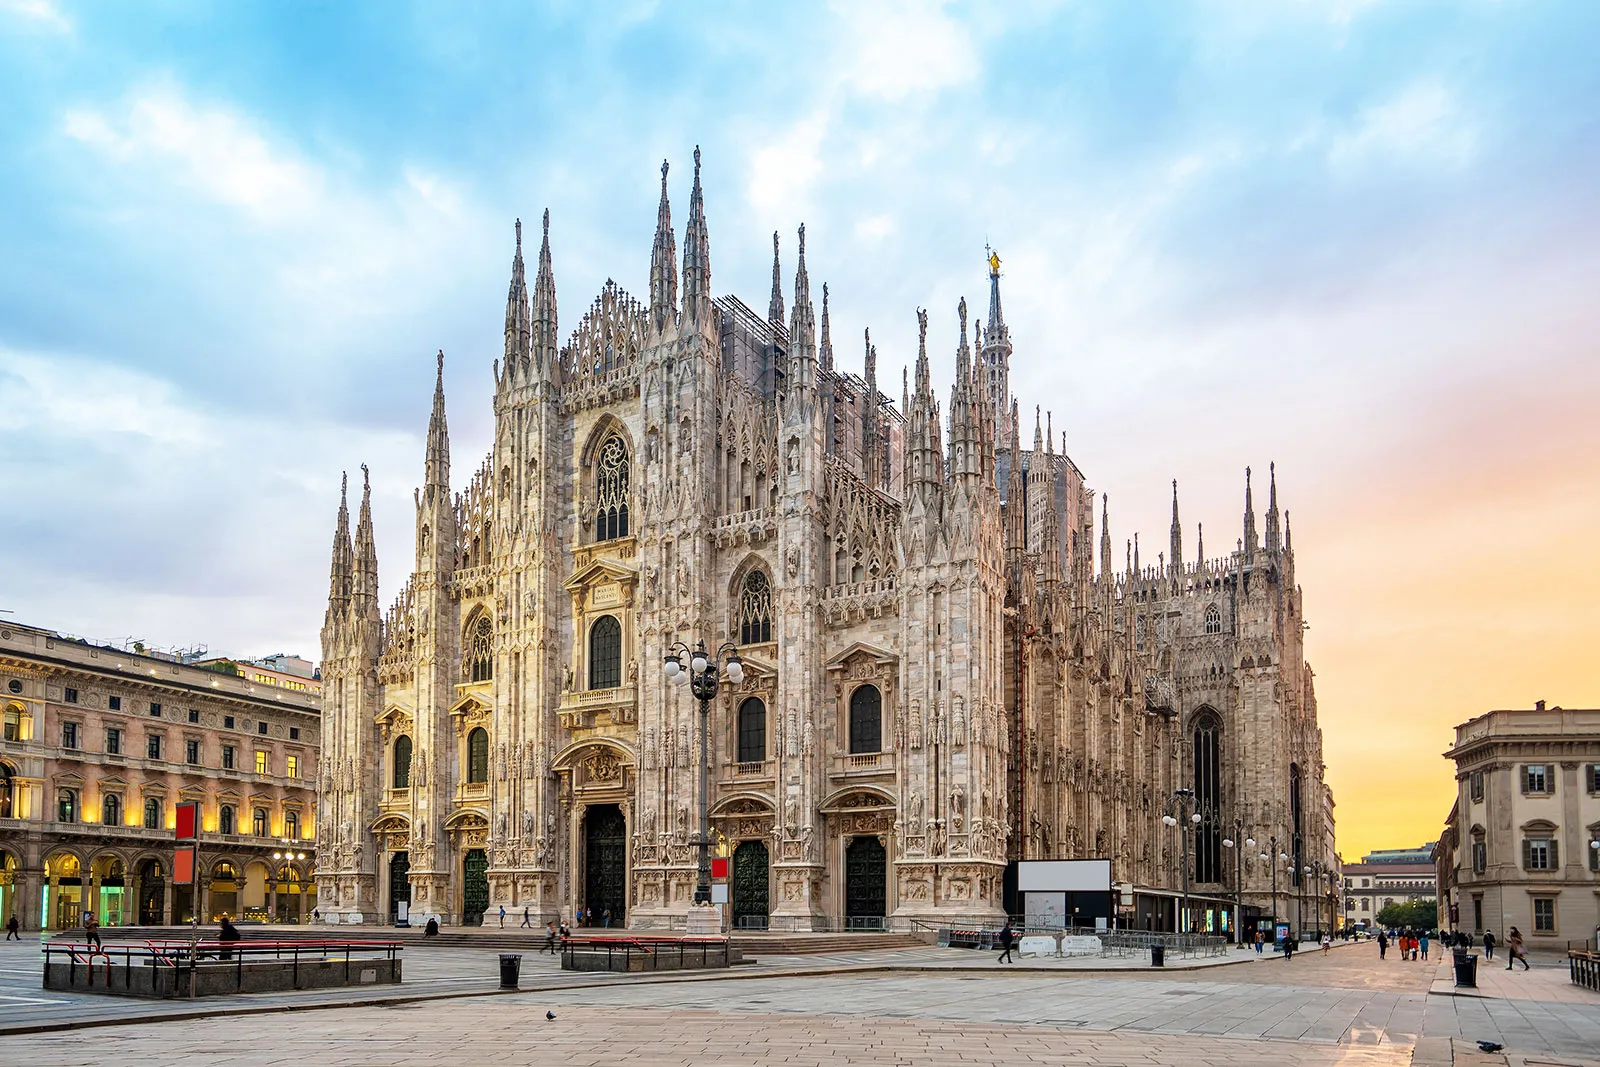What might be some interesting architectural features to explore from inside the cathedral? Inside the Milan Cathedral, visitors can marvel at the vast nave supported by towering columns, beautifully stained glass windows that depict biblical stories, and intricately designed altars and chapels. The grandeur of the ceiling, adorned with frescoes and gothic details, offers a captivating view upwards. Additionally, the crypt, which holds the remains of notable figures, and the unique opportunity to climb to the rooftop for a closer look at the spires and a panoramic view of Milan, provide a rich and immersive experience. Can you describe a short scenario of a family visiting the cathedral for the first time? A family steps into the awe-inspiring Milan Cathedral, their expressions moving from curious anticipation to amazement. The children gaze up in wonder at the towering columns and vibrant stained glass windows, while the parents read aloud details from a guidebook. As they explore, the family feels enveloped by the history and sacredness of the space, creating memories of their shared experience in this breathtaking monument. Can you guide me through an extremely detailed virtual tour of the interior and exterior of the cathedral? Welcome to our detailed virtual tour of the Milan Cathedral. As you stand before the cathedral, observe the intricate façade with its multitude of spires reaching for the sky, each adorned with ornate statues and carvings. Step inside through the massive bronze doors and be greeted by the expansive nave, where towering columns rise to meet a lofty ceiling filled with delicate gothic arches. The light filters through the stained glass windows, casting an array of colors on the marble floor below. Move towards the altar, where exquisite religious artwork and sculptures draw your attention. Each side chapel tells its own story, from the splendidly decorated altars to the crypts holding historical relics. Don't miss the opportunity to ascend to the rooftop, where the close-up view of the spires reveals detailed craftsmanship often missed from below, and the panoramic view of Milan stretches out in all directions. This visual journey envelops you in the history, art, and spiritual significance encapsulated within and around the Milan Cathedral. 